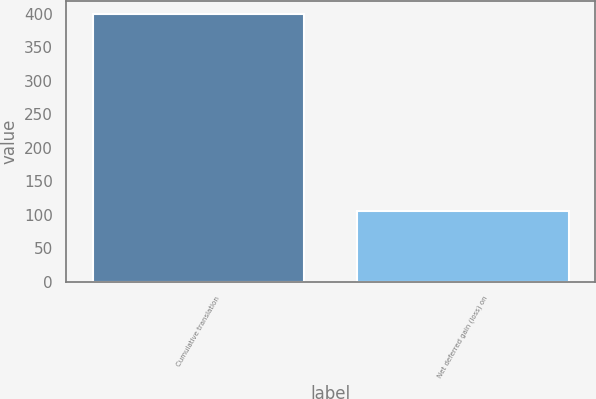Convert chart to OTSL. <chart><loc_0><loc_0><loc_500><loc_500><bar_chart><fcel>Cumulative translation<fcel>Net deferred gain (loss) on<nl><fcel>399.9<fcel>105<nl></chart> 